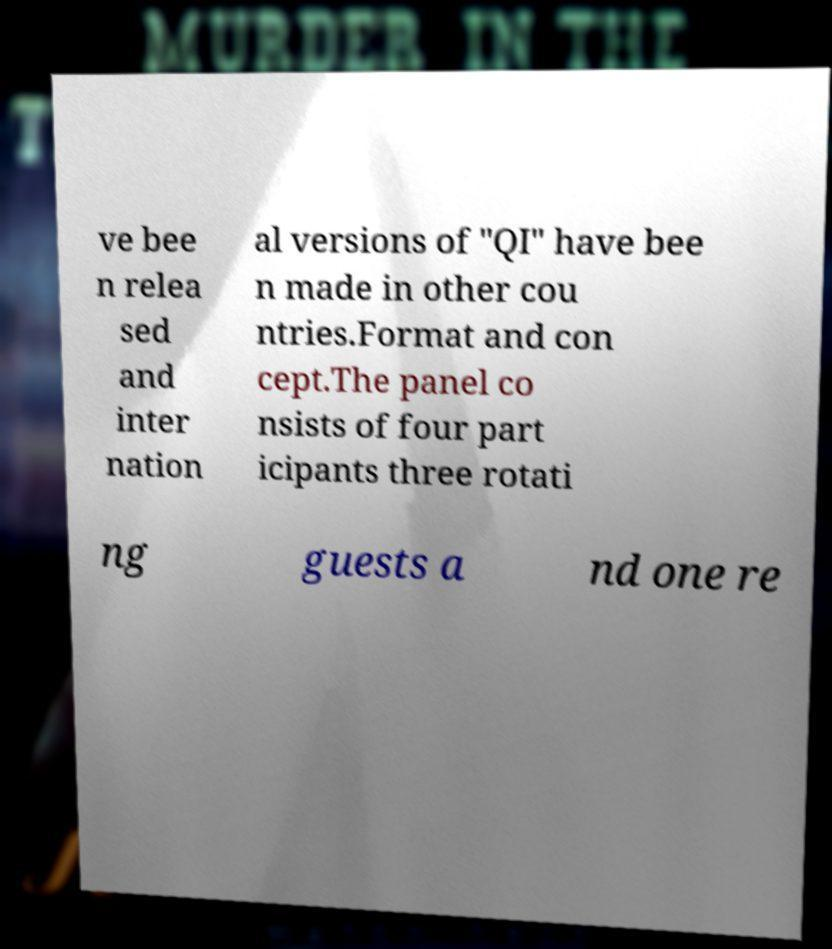Could you extract and type out the text from this image? ve bee n relea sed and inter nation al versions of "QI" have bee n made in other cou ntries.Format and con cept.The panel co nsists of four part icipants three rotati ng guests a nd one re 